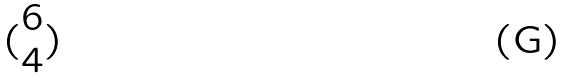<formula> <loc_0><loc_0><loc_500><loc_500>( \begin{matrix} 6 \\ 4 \end{matrix} )</formula> 